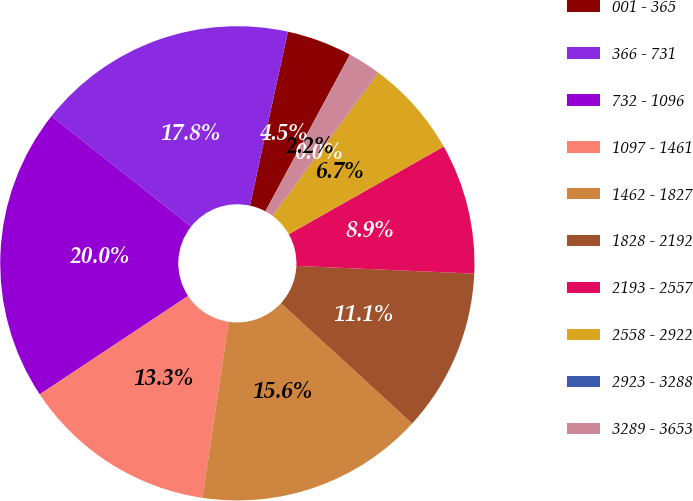Convert chart. <chart><loc_0><loc_0><loc_500><loc_500><pie_chart><fcel>001 - 365<fcel>366 - 731<fcel>732 - 1096<fcel>1097 - 1461<fcel>1462 - 1827<fcel>1828 - 2192<fcel>2193 - 2557<fcel>2558 - 2922<fcel>2923 - 3288<fcel>3289 - 3653<nl><fcel>4.45%<fcel>17.76%<fcel>19.98%<fcel>13.33%<fcel>15.55%<fcel>11.11%<fcel>8.89%<fcel>6.67%<fcel>0.02%<fcel>2.24%<nl></chart> 